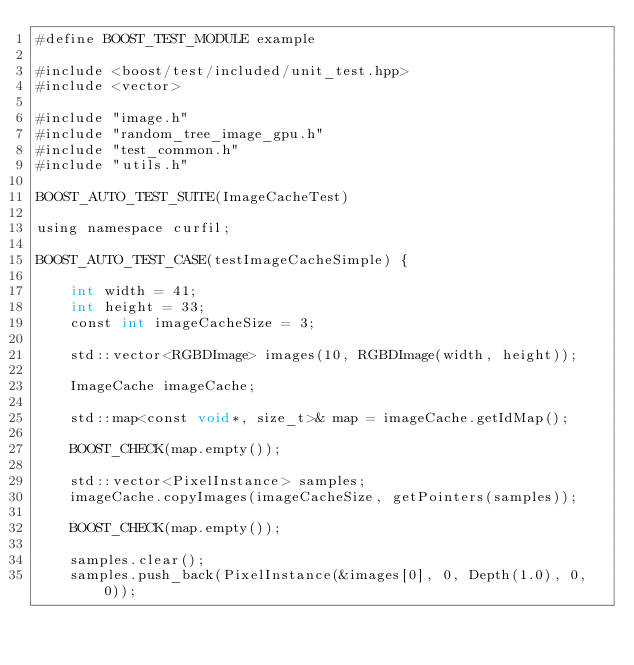<code> <loc_0><loc_0><loc_500><loc_500><_Cuda_>#define BOOST_TEST_MODULE example

#include <boost/test/included/unit_test.hpp>
#include <vector>

#include "image.h"
#include "random_tree_image_gpu.h"
#include "test_common.h"
#include "utils.h"

BOOST_AUTO_TEST_SUITE(ImageCacheTest)

using namespace curfil;

BOOST_AUTO_TEST_CASE(testImageCacheSimple) {

    int width = 41;
    int height = 33;
    const int imageCacheSize = 3;

    std::vector<RGBDImage> images(10, RGBDImage(width, height));

    ImageCache imageCache;

    std::map<const void*, size_t>& map = imageCache.getIdMap();

    BOOST_CHECK(map.empty());

    std::vector<PixelInstance> samples;
    imageCache.copyImages(imageCacheSize, getPointers(samples));

    BOOST_CHECK(map.empty());

    samples.clear();
    samples.push_back(PixelInstance(&images[0], 0, Depth(1.0), 0, 0));</code> 